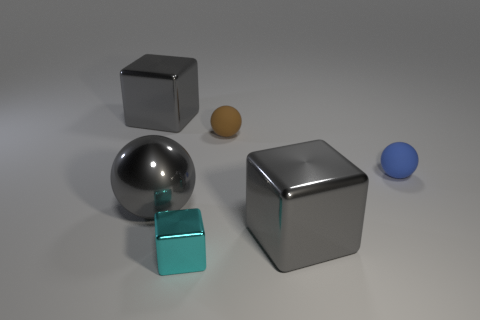Is the number of big gray shiny things that are behind the tiny brown sphere the same as the number of blue matte spheres right of the shiny ball?
Your response must be concise. Yes. Is the gray block that is on the right side of the small shiny thing made of the same material as the small cube?
Provide a succinct answer. Yes. The thing that is both in front of the small blue matte ball and on the right side of the small brown ball is what color?
Provide a succinct answer. Gray. There is a shiny cube that is behind the small brown ball; how many things are to the left of it?
Give a very brief answer. 0. What material is the big gray thing that is the same shape as the tiny brown matte thing?
Your response must be concise. Metal. The tiny cube is what color?
Provide a short and direct response. Cyan. What number of things are cyan shiny things or large cyan blocks?
Offer a terse response. 1. There is a small rubber thing that is to the left of the tiny blue rubber sphere behind the shiny sphere; what shape is it?
Your answer should be very brief. Sphere. What number of other things are there of the same material as the blue ball
Give a very brief answer. 1. Do the blue thing and the big block that is left of the cyan object have the same material?
Give a very brief answer. No. 